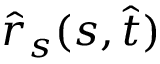<formula> <loc_0><loc_0><loc_500><loc_500>\hat { r } _ { s } ( s , \hat { t } )</formula> 